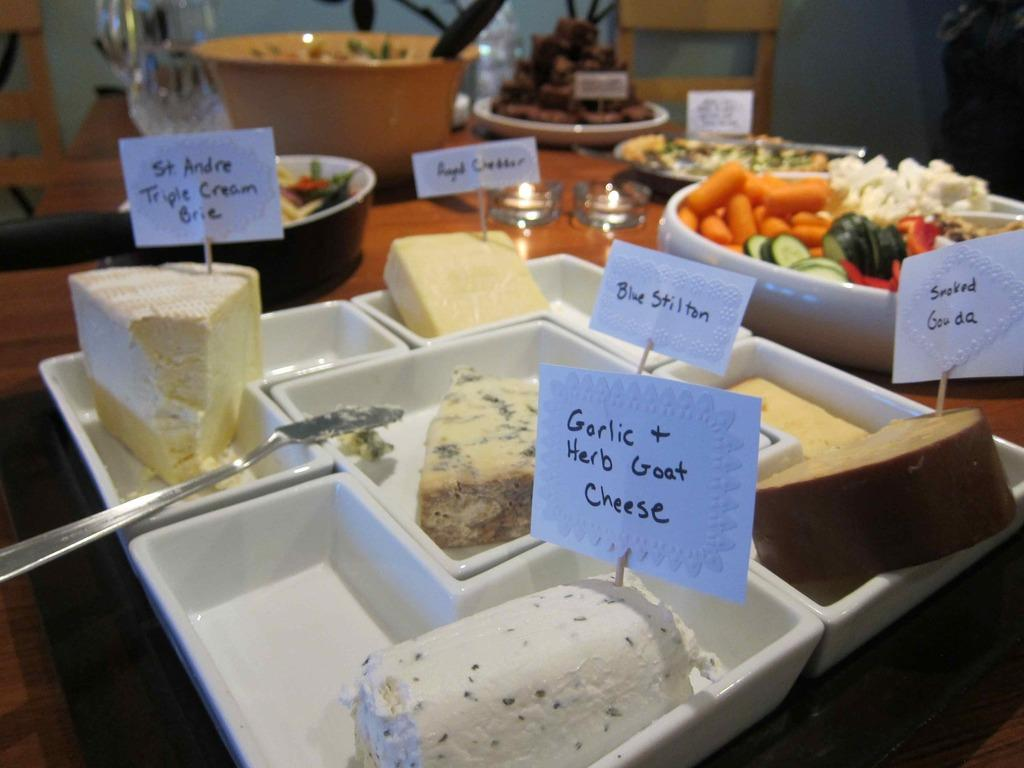What is on the plate that is visible in the image? There is food on a plate in the image. What type of food can be seen on the plate? The food on the plate consists of vegetables. What else is visible in the image besides the plate of food? There are glasses in the image. What type of owl can be seen sitting on the plate in the image? There is no owl present in the image; it only features a plate of food and glasses. 